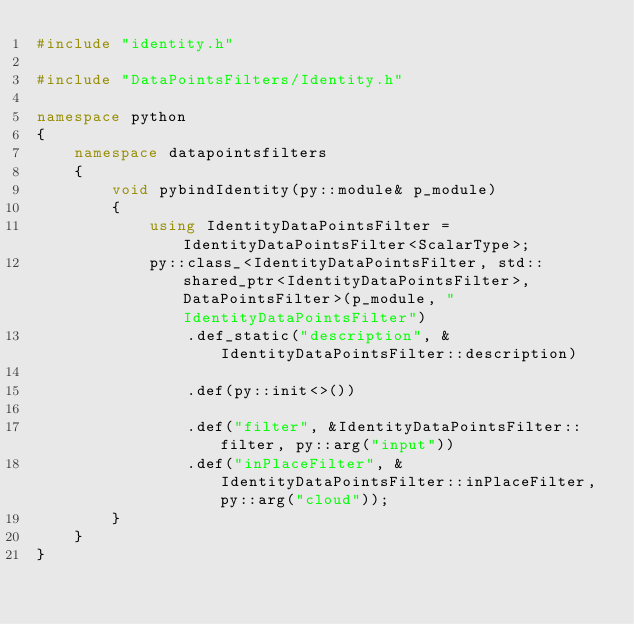Convert code to text. <code><loc_0><loc_0><loc_500><loc_500><_C++_>#include "identity.h"

#include "DataPointsFilters/Identity.h"

namespace python
{
	namespace datapointsfilters
	{
		void pybindIdentity(py::module& p_module)
		{
			using IdentityDataPointsFilter = IdentityDataPointsFilter<ScalarType>;
			py::class_<IdentityDataPointsFilter, std::shared_ptr<IdentityDataPointsFilter>, DataPointsFilter>(p_module, "IdentityDataPointsFilter")
				.def_static("description", &IdentityDataPointsFilter::description)

				.def(py::init<>())

				.def("filter", &IdentityDataPointsFilter::filter, py::arg("input"))
				.def("inPlaceFilter", &IdentityDataPointsFilter::inPlaceFilter, py::arg("cloud"));
		}
	}
}
</code> 